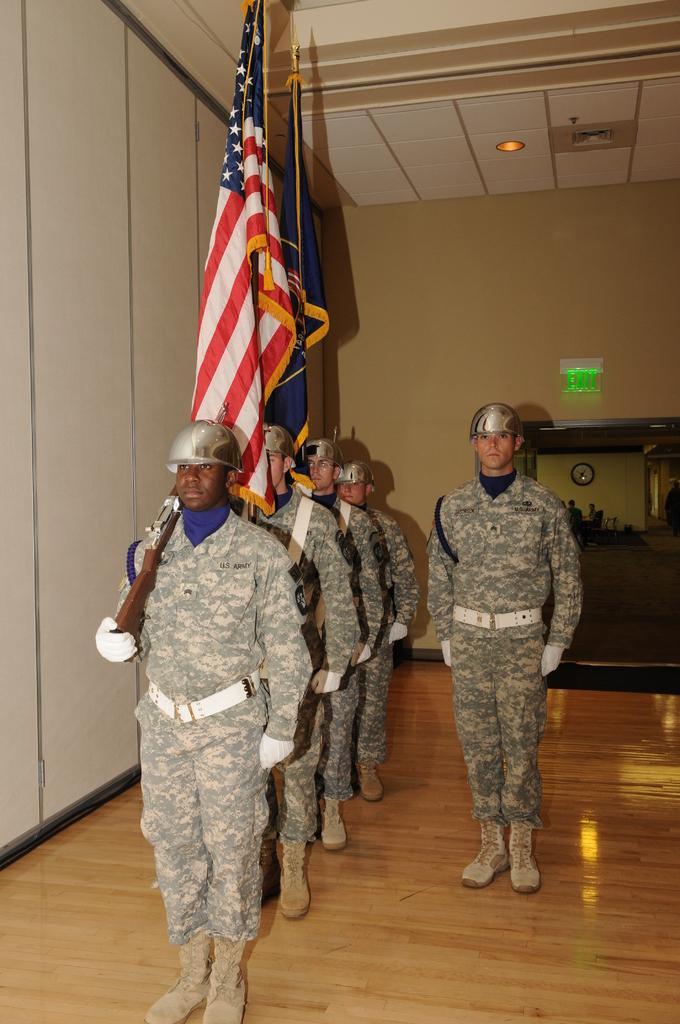Could you give a brief overview of what you see in this image? In this image we can see people standing. They are wearing uniforms. The man in the first is holding a rifle. In the background there are flags, wall and a door. 